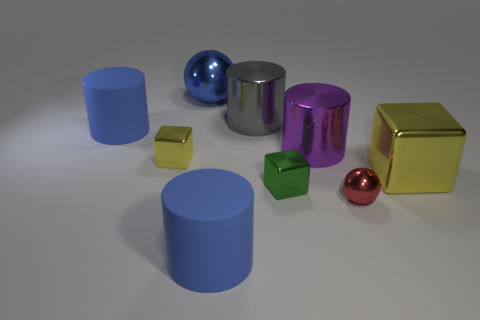Add 1 blue rubber cylinders. How many objects exist? 10 Subtract all cylinders. How many objects are left? 5 Add 3 purple things. How many purple things exist? 4 Subtract 1 purple cylinders. How many objects are left? 8 Subtract all blue things. Subtract all big blue cylinders. How many objects are left? 4 Add 5 big balls. How many big balls are left? 6 